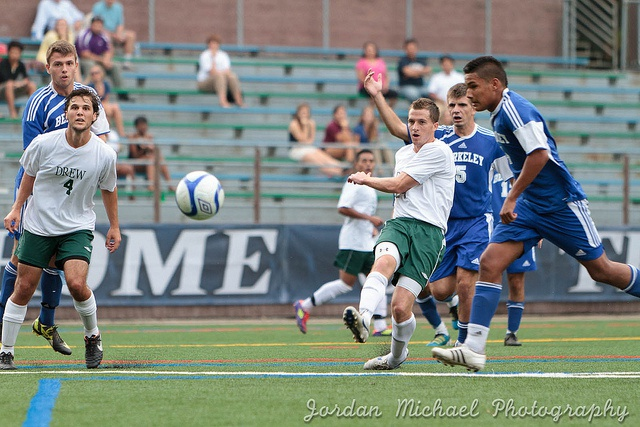Describe the objects in this image and their specific colors. I can see people in gray, darkgray, lightgray, and black tones, people in gray, black, navy, lightgray, and maroon tones, people in gray, lightgray, teal, darkgray, and black tones, people in gray, blue, navy, and lightgray tones, and people in gray, black, white, and blue tones in this image. 